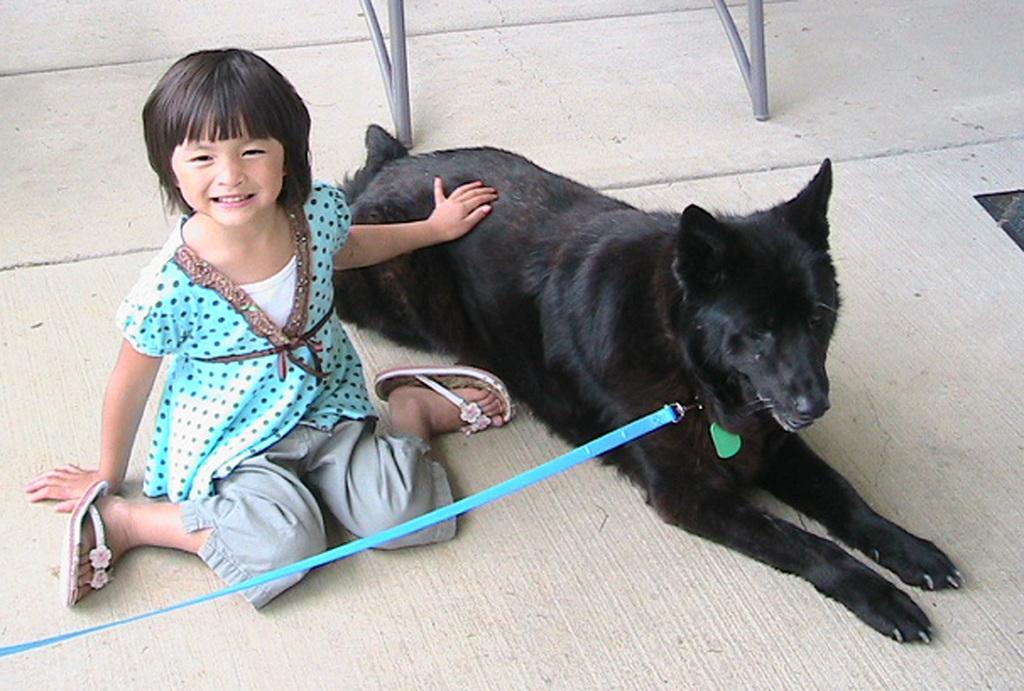Could you give a brief overview of what you see in this image? In this picture a small girl who is blue dressed is holding a black dog. The dog also has a blue color belt attached to it. There is a grey color chair in the background. 